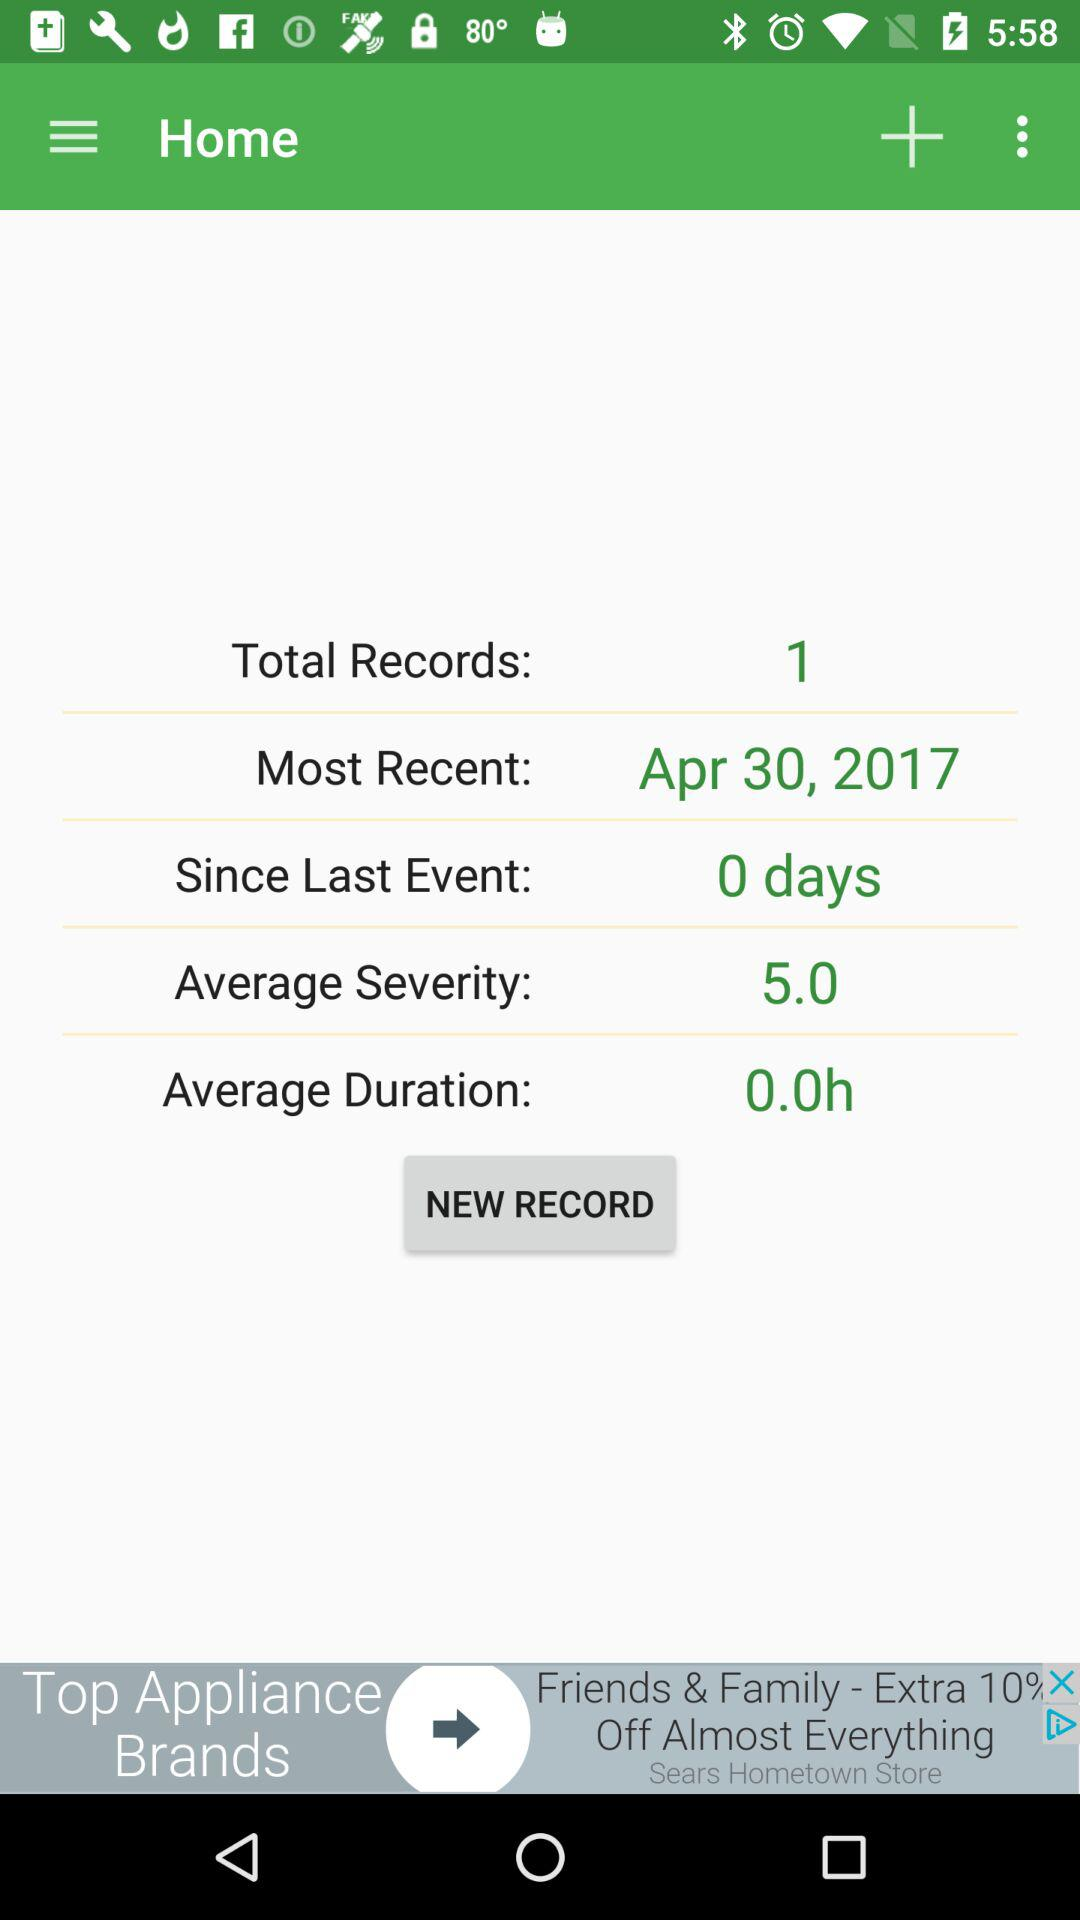What is the average duration of records? The average duration is 0 hours. 